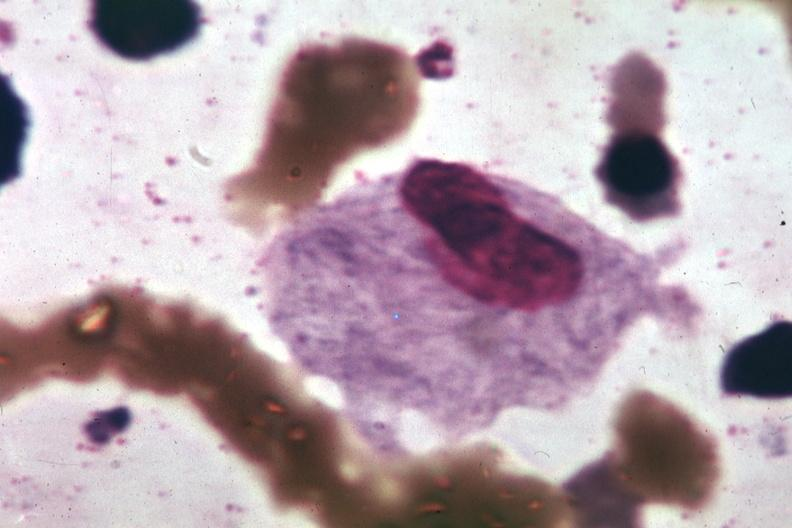s gaucher cell present?
Answer the question using a single word or phrase. Yes 